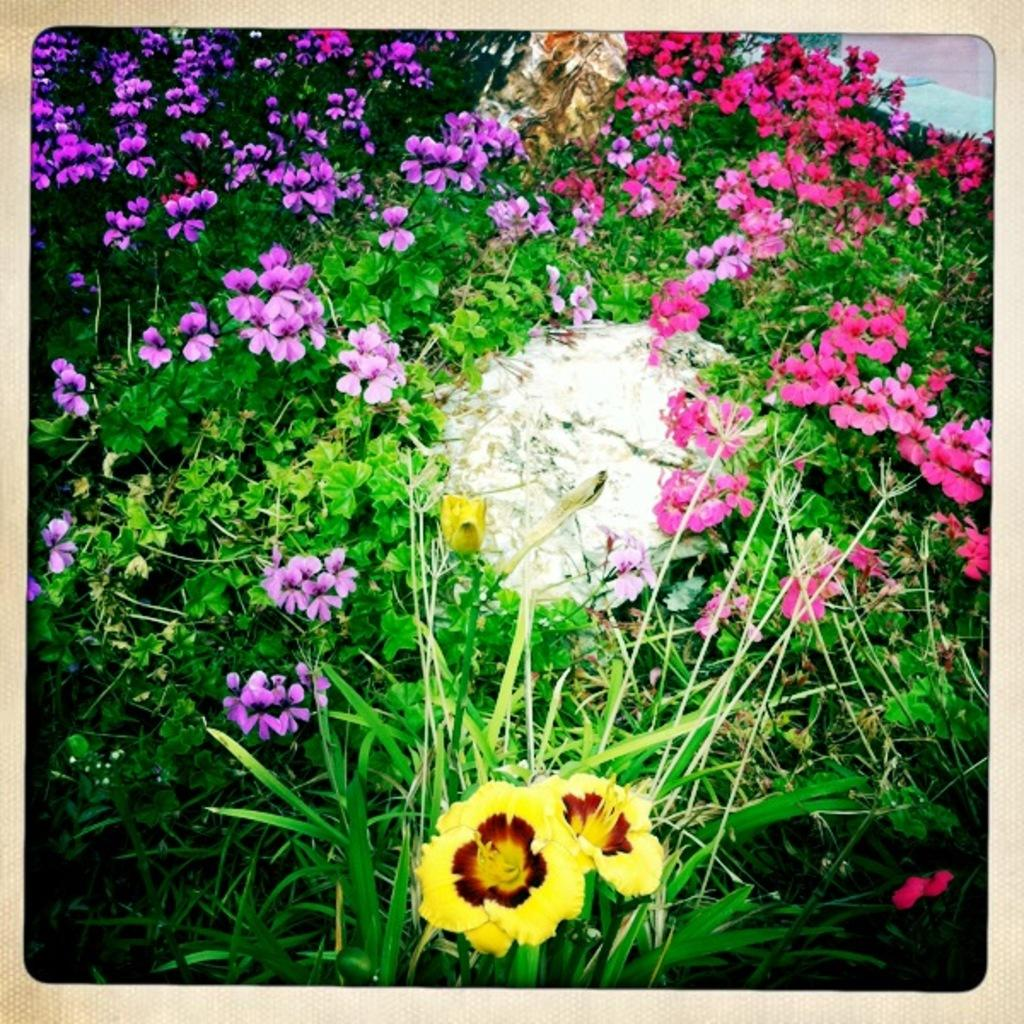Where was the image taken? The image was taken outdoors. What can be seen in the image besides the outdoor setting? There are many plants in the image. What is unique about the plants in the image? The plants have flowers with different colors. How does the image show the stomach of a person? The image does not show the stomach of a person; it features plants with flowers of different colors in an outdoor setting. 